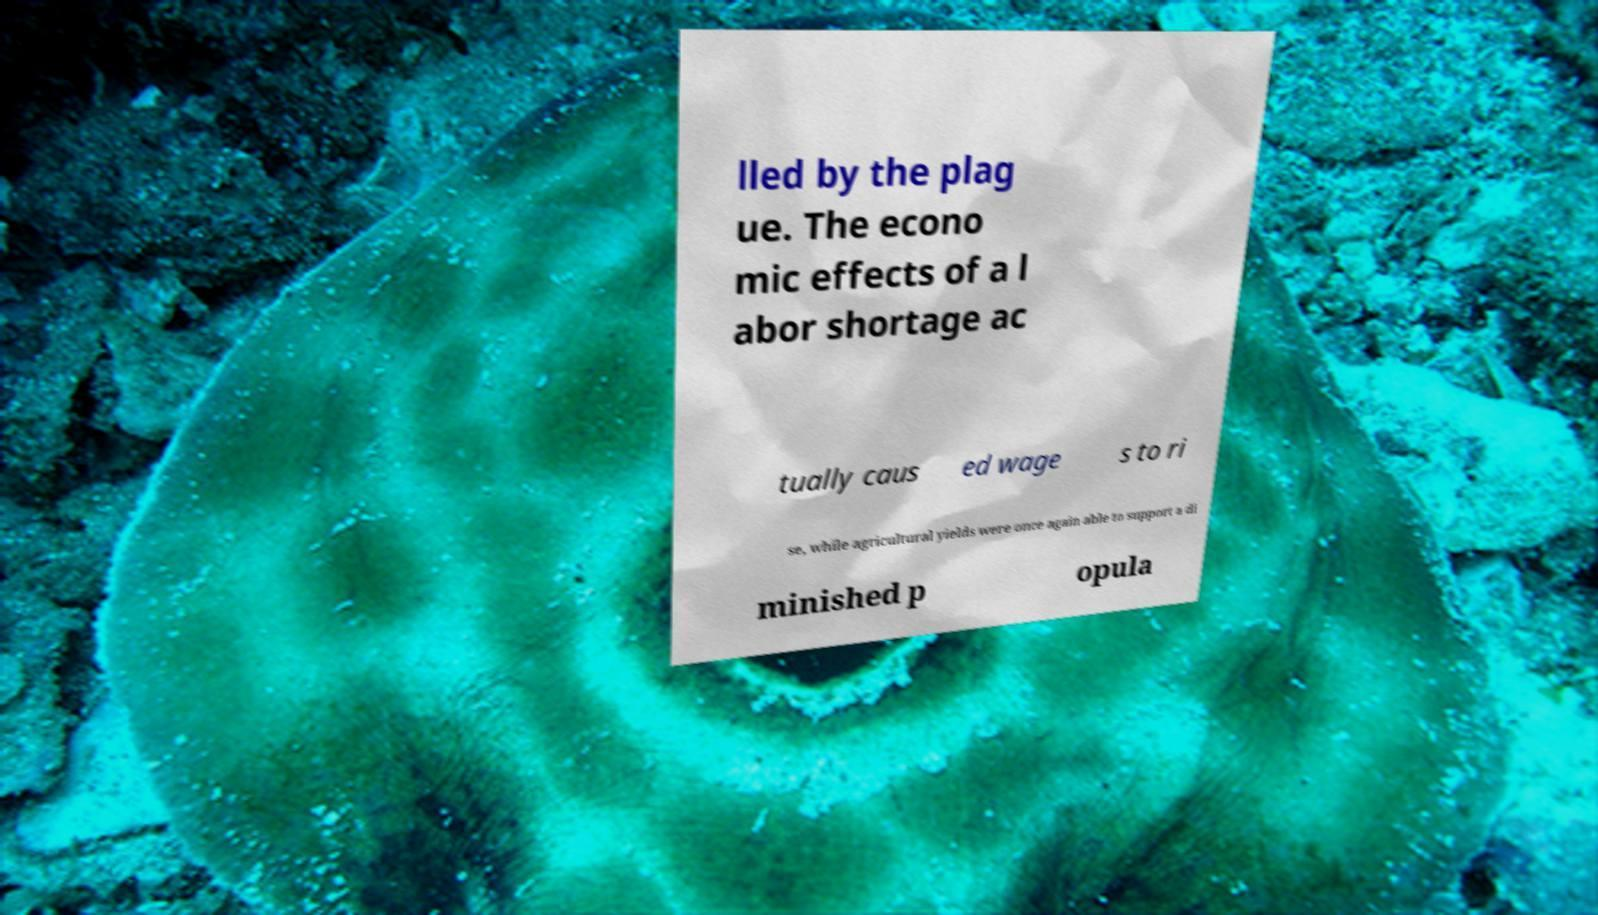There's text embedded in this image that I need extracted. Can you transcribe it verbatim? lled by the plag ue. The econo mic effects of a l abor shortage ac tually caus ed wage s to ri se, while agricultural yields were once again able to support a di minished p opula 